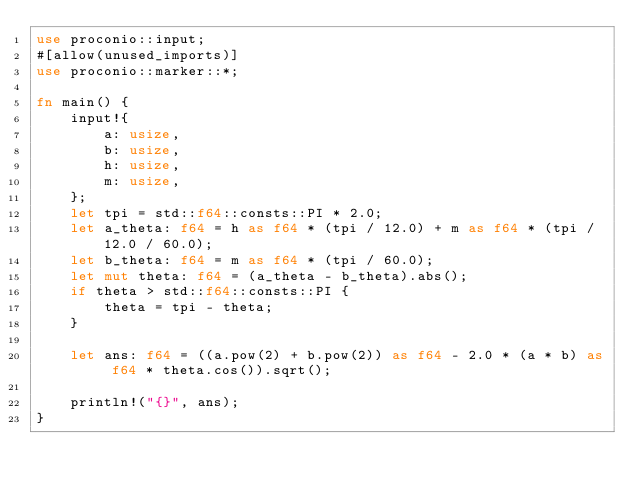<code> <loc_0><loc_0><loc_500><loc_500><_Rust_>use proconio::input;
#[allow(unused_imports)]
use proconio::marker::*;

fn main() {
    input!{
        a: usize,
        b: usize,
        h: usize,
        m: usize,
    };
    let tpi = std::f64::consts::PI * 2.0;
    let a_theta: f64 = h as f64 * (tpi / 12.0) + m as f64 * (tpi / 12.0 / 60.0);
    let b_theta: f64 = m as f64 * (tpi / 60.0);
    let mut theta: f64 = (a_theta - b_theta).abs();
    if theta > std::f64::consts::PI {
        theta = tpi - theta;
    }

    let ans: f64 = ((a.pow(2) + b.pow(2)) as f64 - 2.0 * (a * b) as f64 * theta.cos()).sqrt();

    println!("{}", ans);
}
</code> 